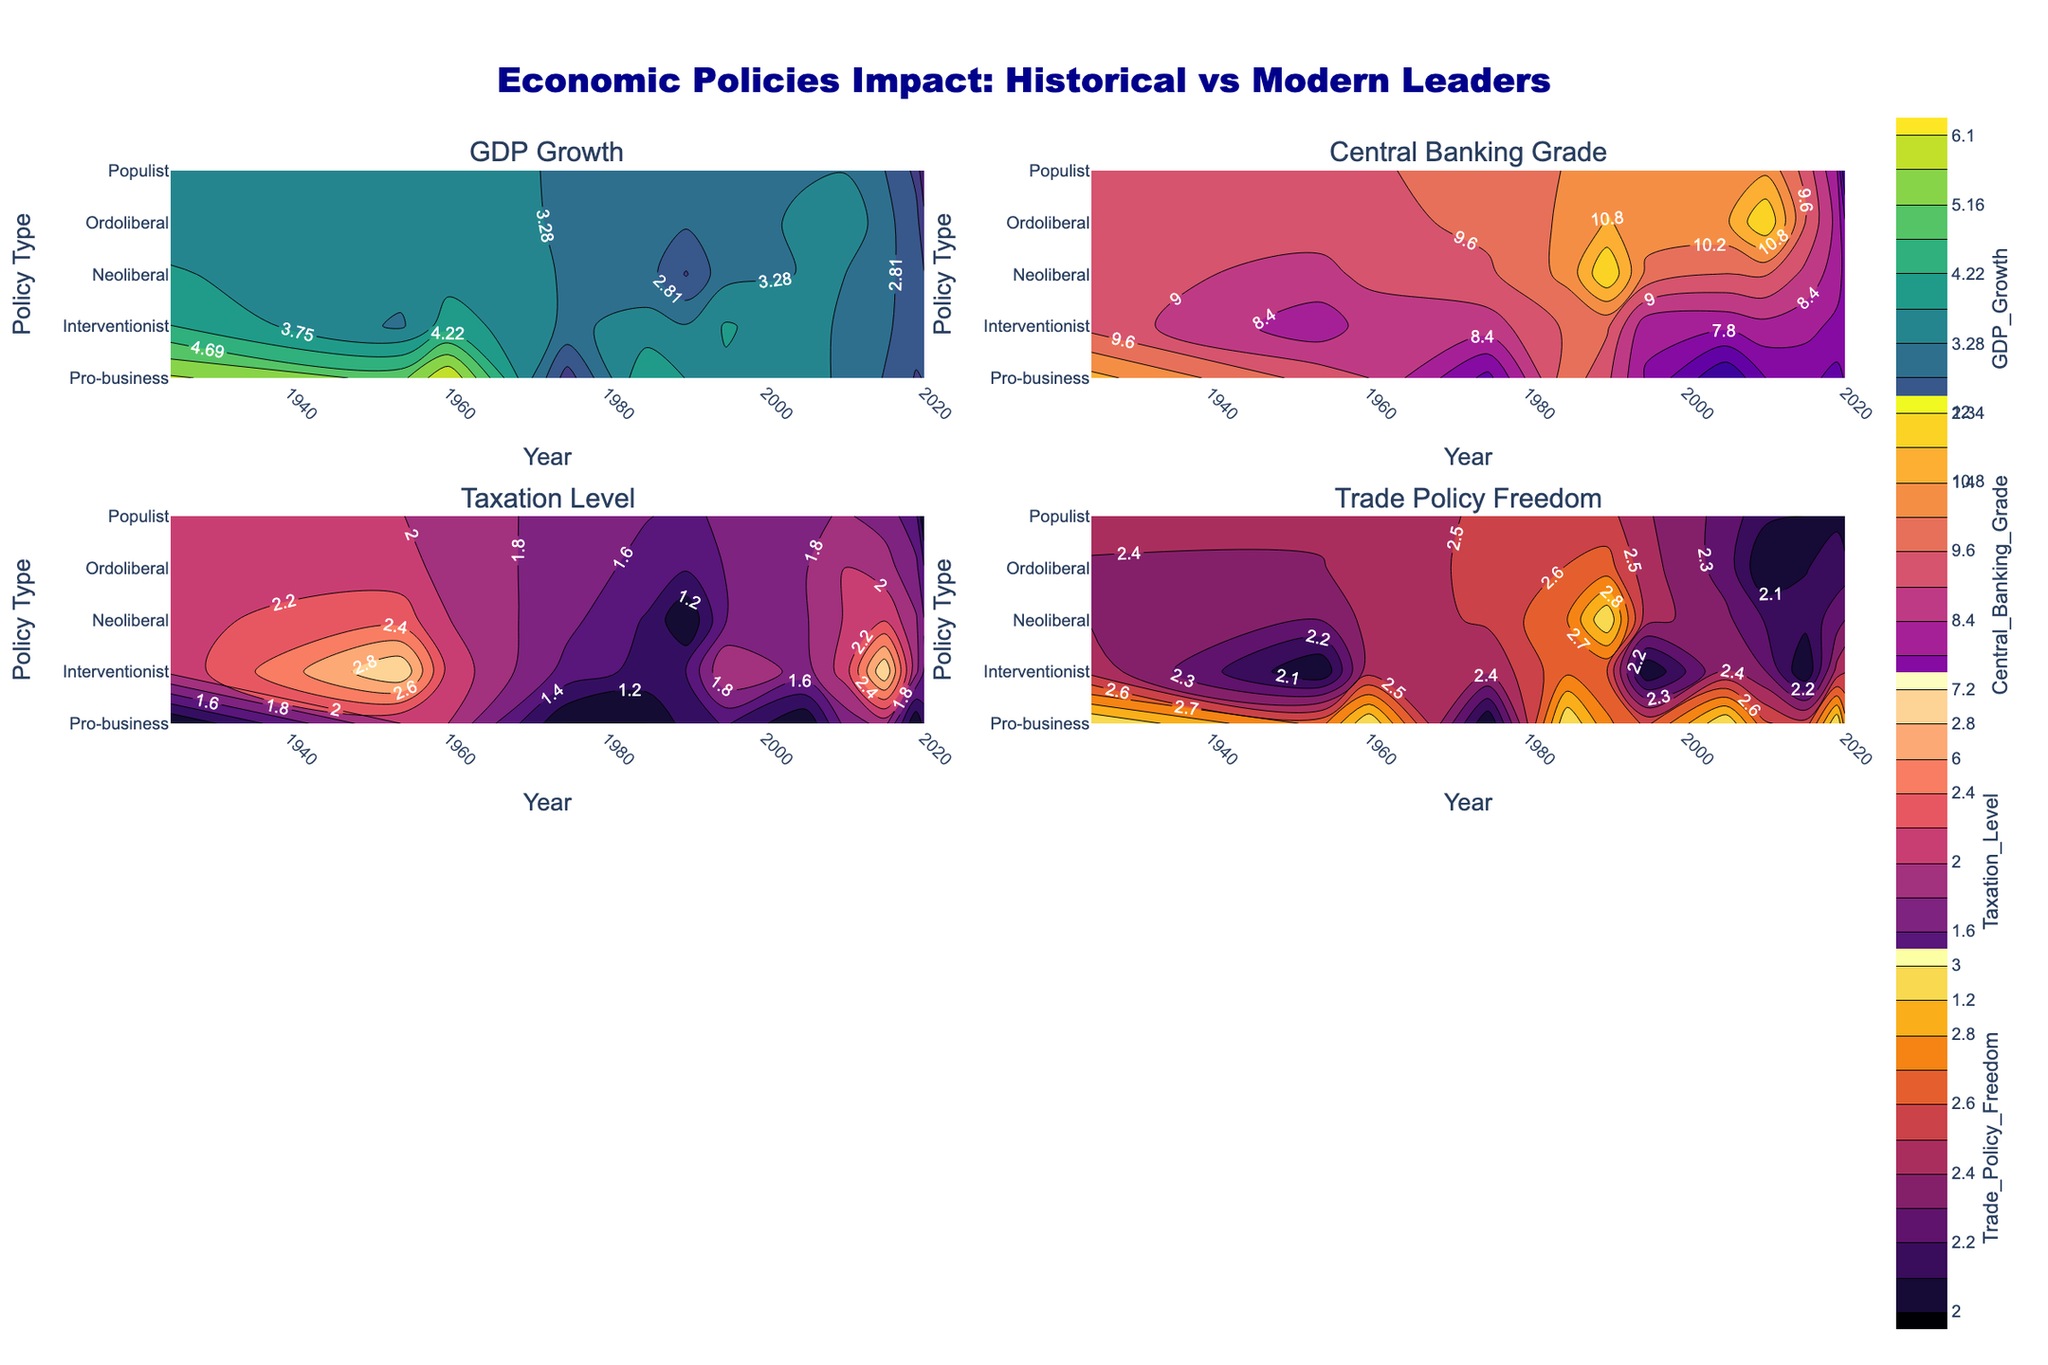Which leader implemented a pro-business policy that led to the highest GDP growth? According to the contour plot for GDP Growth, the leader who implemented a pro-business policy with the highest GDP growth is John F. Kennedy in 1960, where the contour levels confirm a high GDP growth value.
Answer: John F. Kennedy Which policy type generally corresponds to the highest Central Banking Grade in the contour plot? Analyzing the contour plot for Central Banking Grade, it appears that pro-business and neoliberal policies are generally associated with the highest grades (A, A-, and A+).
Answer: Pro-business and neoliberal In which year did interventionist policies yield the lowest GDP growth? According to the contour plot for GDP Growth, Barack Obama's interventionist policy in 2015 yielded the lowest GDP growth among interventionist policies.
Answer: 2015 How does the Trade Policy Freedom vary for pro-business policies compared to interventionist policies? The contour plot for Trade Policy Freedom shows that pro-business policies typically have high trade policy freedom, while interventionist policies tend to have medium trade policy freedom. This comparison can be identified by the contour levels differing for the two policy types.
Answer: Pro-business: high, interventionist: medium During which years did pro-business policies show consistent GDP growth? From the contour plot for GDP Growth, years such as 1960 (John F. Kennedy), 1985 (Ronald Reagan), and 2005 (George W. Bush) show consistent and relatively higher GDP growth under pro-business policies.
Answer: 1960, 1985, 2005 Which leader had the highest Taxation Level and what was their policy type? The contour plot for Taxation Level indicates that Dwight D. Eisenhower, who had an interventionist policy type, had the highest taxation level.
Answer: Dwight D. Eisenhower, Interventionist Compare the Central Banking Grades for leaders with interventionist policies in 1954 and 2015. The contour plot for Central Banking Grade shows that in 1954 under Dwight D. Eisenhower with an interventionist policy, the grade was B. In 2015 under Barack Obama, also with an interventionist policy, the grade was B.
Answer: Both B What is the Trade Policy Freedom level during George W. Bush's presidency with a pro-business policy? According to the contour plot for Trade Policy Freedom, George W. Bush's pro-business policy in 2005 was associated with a high level of trade policy freedom.
Answer: High How does Taxation Level change between Margaret Thatcher's neoliberal policy and Barack Obama's interventionist policy? The contour plot for Taxation Level shows that Margaret Thatcher's neoliberal policy had low taxation levels, whereas Barack Obama's interventionist policy had high taxation levels.
Answer: Thatcher: Low, Obama: High What year correlates to the lowest Central Banking Grade among the leaders shown, and what was the policy type? Based on the contour plot for Central Banking Grade, the lowest grade of C appears in 2005 (George W. Bush with a pro-business policy) and 2020 (Boris Johnson with a populist policy).
Answer: 2005 (pro-business) and 2020 (populist) 